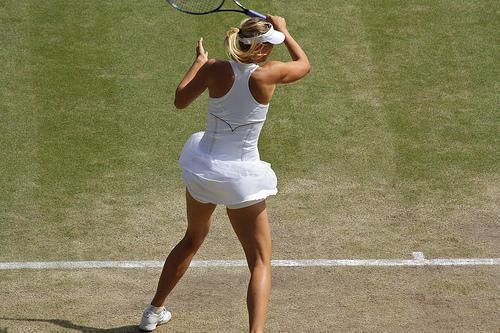How many people are in the photo?
Give a very brief answer. 1. 